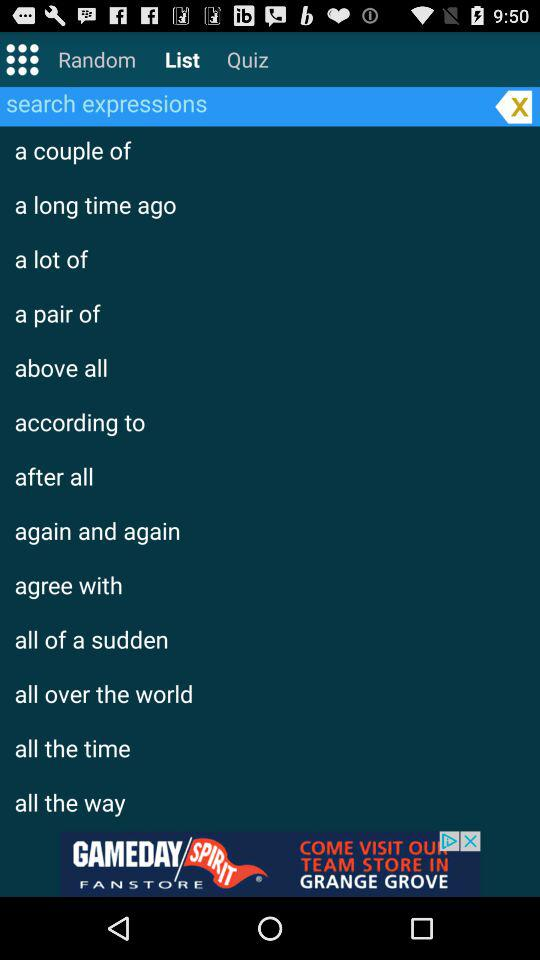Which option is selected? The selected option is "List". 